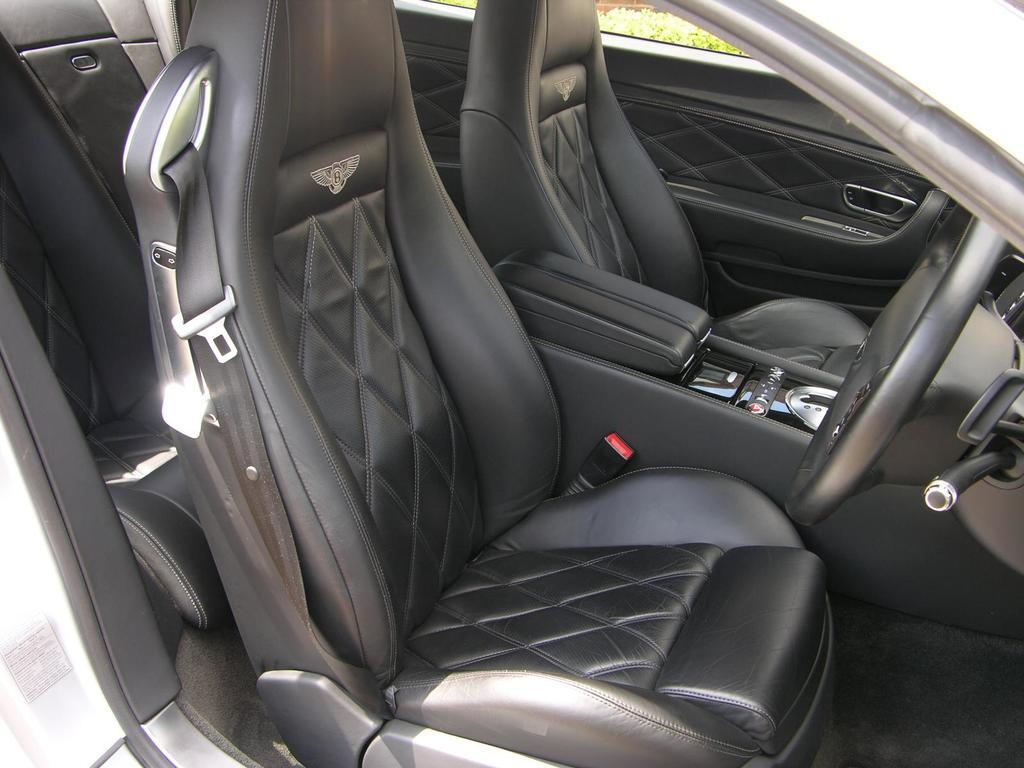What type of vehicle is shown in the image? The image shows an inside view of a car. What can be found inside the car? There are seats in the car. Where is the steering wheel located in the image? The steering wheel is on the right side of the image. What type of drink is being served in the middle of the car? There is no drink or any indication of a drink being served in the image. 